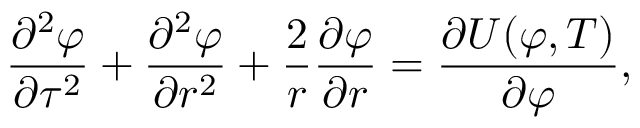Convert formula to latex. <formula><loc_0><loc_0><loc_500><loc_500>{ \frac { \partial ^ { 2 } \varphi } { \partial \tau ^ { 2 } } } + { \frac { \partial ^ { 2 } \varphi } { \partial r ^ { 2 } } } + { \frac { 2 } { r } } { \frac { \partial \varphi } { \partial r } } = { \frac { \partial U ( \varphi , T ) } { \partial \varphi } } ,</formula> 